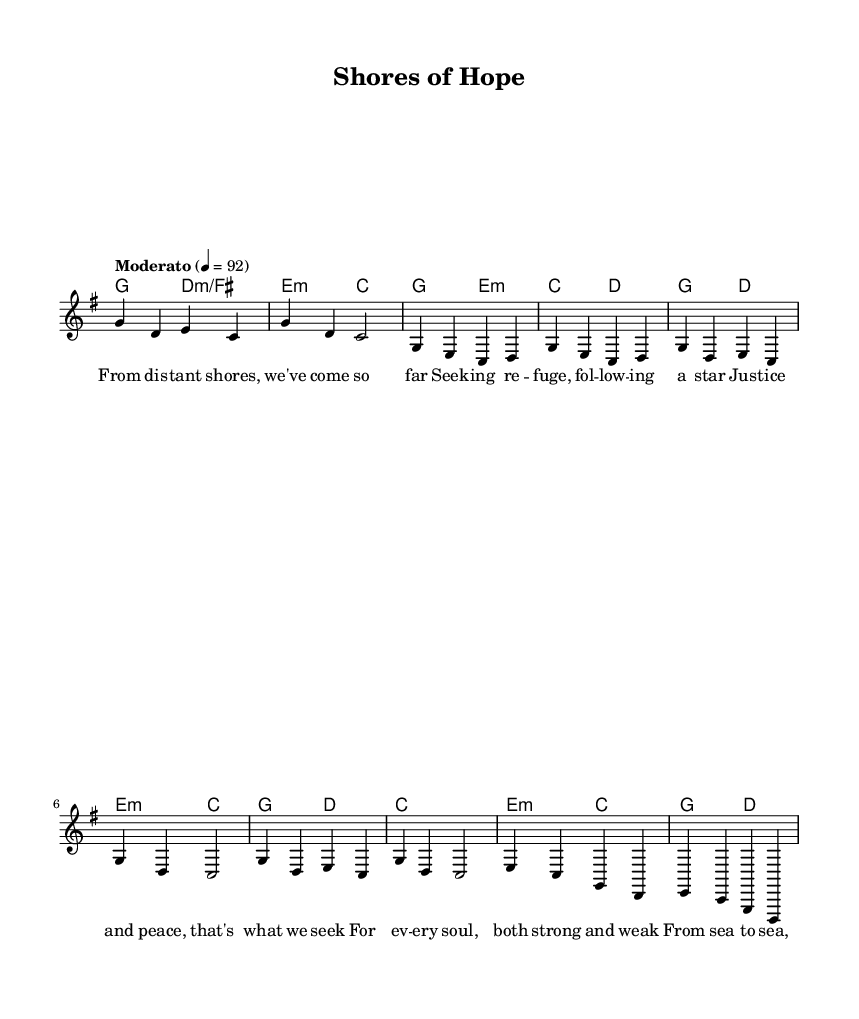What is the key signature of this music? The key signature is G major, which has one sharp (F#). This can be identified from the beginning of the sheet music, where the key is specified in the global section.
Answer: G major What is the time signature of this music? The time signature is 4/4, indicated at the beginning of the global section as well. It means there are four beats in each measure.
Answer: 4/4 What tempo marking is indicated for this piece? The piece has a tempo marking of "Moderato" with a tempo of 92 beats per minute. This is found in the global section where the tempo is specified.
Answer: Moderato 92 How many measures are in the chorus section? The chorus section consists of four measures, as can be determined by counting the measures in the melody as indicated in the sheet music.
Answer: 4 What is the primary theme of the lyrics in this piece? The primary theme of the lyrics emphasizes justice and peace, as seen in the lyrics that express seeking justice for every soul and freedom across lands. This theme aligns with the social justice focus of the song.
Answer: Justice and peace What chord follows the first measure of the bridge? The chord following the first measure of the bridge is C major, indicated within the chord mode section, which specifies the harmonies played alongside the melody.
Answer: C major How many verses are partially given in the music? There is one complete verse and a partial one indicated in the score. The verse is visible in the words section showing the lyrics that follow the melody arrangement.
Answer: 1 